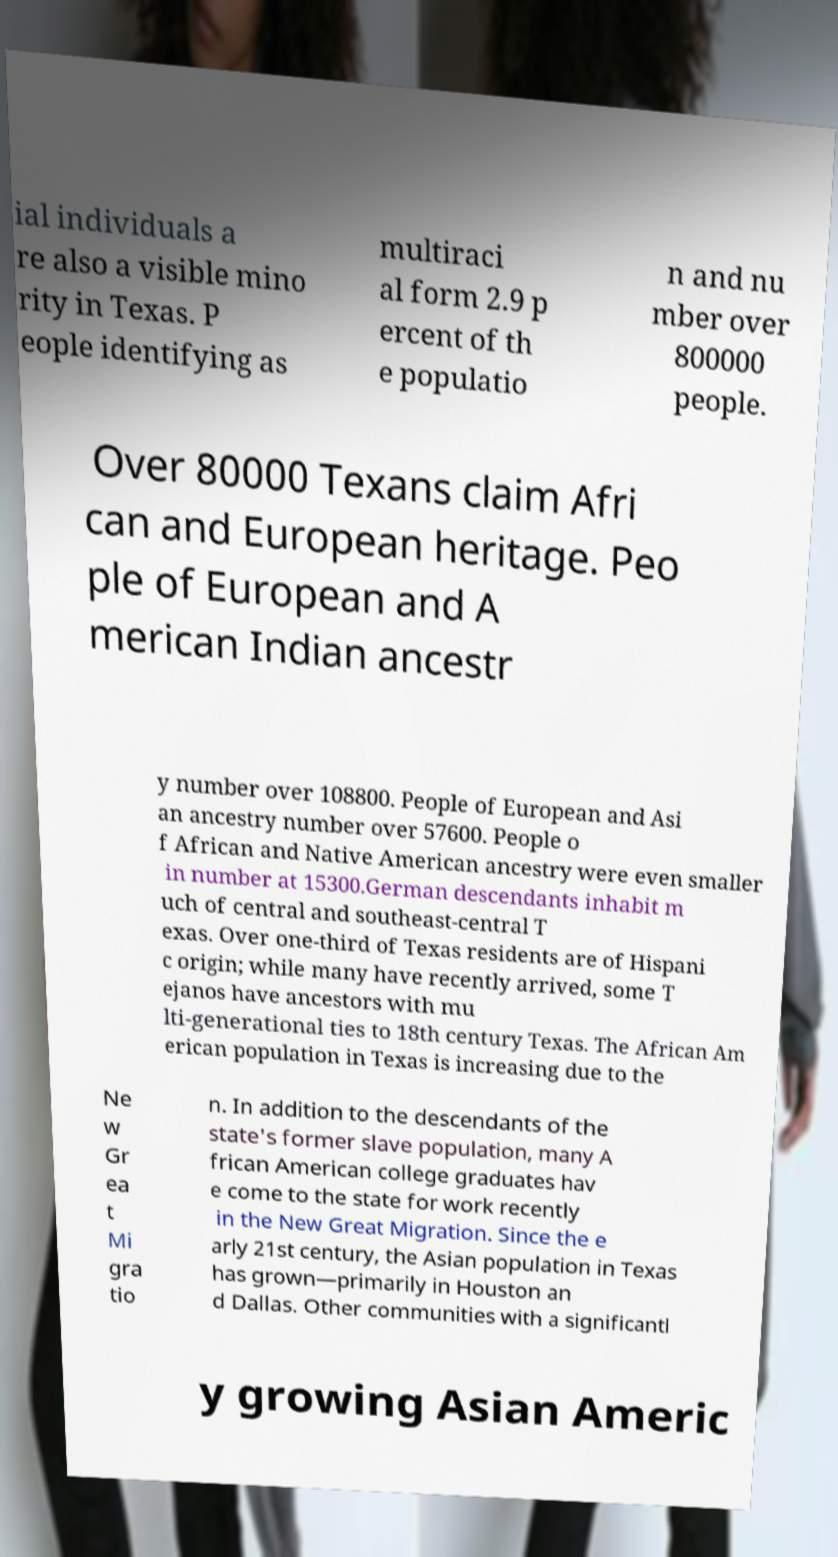Please read and relay the text visible in this image. What does it say? ial individuals a re also a visible mino rity in Texas. P eople identifying as multiraci al form 2.9 p ercent of th e populatio n and nu mber over 800000 people. Over 80000 Texans claim Afri can and European heritage. Peo ple of European and A merican Indian ancestr y number over 108800. People of European and Asi an ancestry number over 57600. People o f African and Native American ancestry were even smaller in number at 15300.German descendants inhabit m uch of central and southeast-central T exas. Over one-third of Texas residents are of Hispani c origin; while many have recently arrived, some T ejanos have ancestors with mu lti-generational ties to 18th century Texas. The African Am erican population in Texas is increasing due to the Ne w Gr ea t Mi gra tio n. In addition to the descendants of the state's former slave population, many A frican American college graduates hav e come to the state for work recently in the New Great Migration. Since the e arly 21st century, the Asian population in Texas has grown—primarily in Houston an d Dallas. Other communities with a significantl y growing Asian Americ 